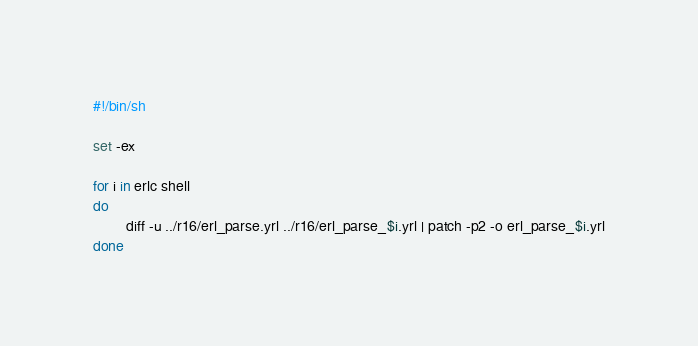<code> <loc_0><loc_0><loc_500><loc_500><_Bash_>#!/bin/sh

set -ex

for i in erlc shell
do
        diff -u ../r16/erl_parse.yrl ../r16/erl_parse_$i.yrl | patch -p2 -o erl_parse_$i.yrl
done

</code> 